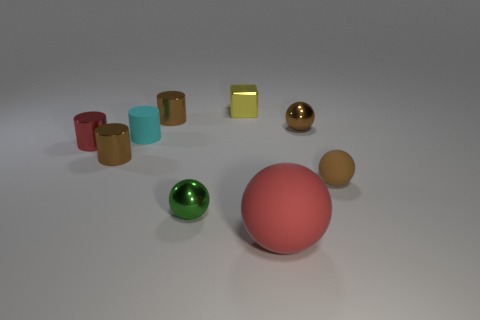Subtract all cylinders. How many objects are left? 5 Subtract all small cyan balls. Subtract all brown cylinders. How many objects are left? 7 Add 7 small brown matte balls. How many small brown matte balls are left? 8 Add 1 metal cubes. How many metal cubes exist? 2 Subtract 0 blue cylinders. How many objects are left? 9 